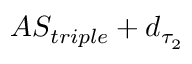Convert formula to latex. <formula><loc_0><loc_0><loc_500><loc_500>A S _ { t r i p l e } + d _ { \tau _ { 2 } }</formula> 